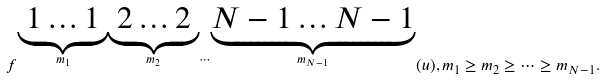Convert formula to latex. <formula><loc_0><loc_0><loc_500><loc_500>f ^ { \stackrel { \underbrace { 1 \dots 1 } } { m _ { 1 } } \stackrel { \underbrace { 2 \dots 2 } } { m _ { 2 } } \cdots \stackrel { \underbrace { N - 1 \dots N - 1 } } { m _ { N - 1 } } } ( u ) , m _ { 1 } \geq m _ { 2 } \geq \dots \geq m _ { N - 1 } .</formula> 